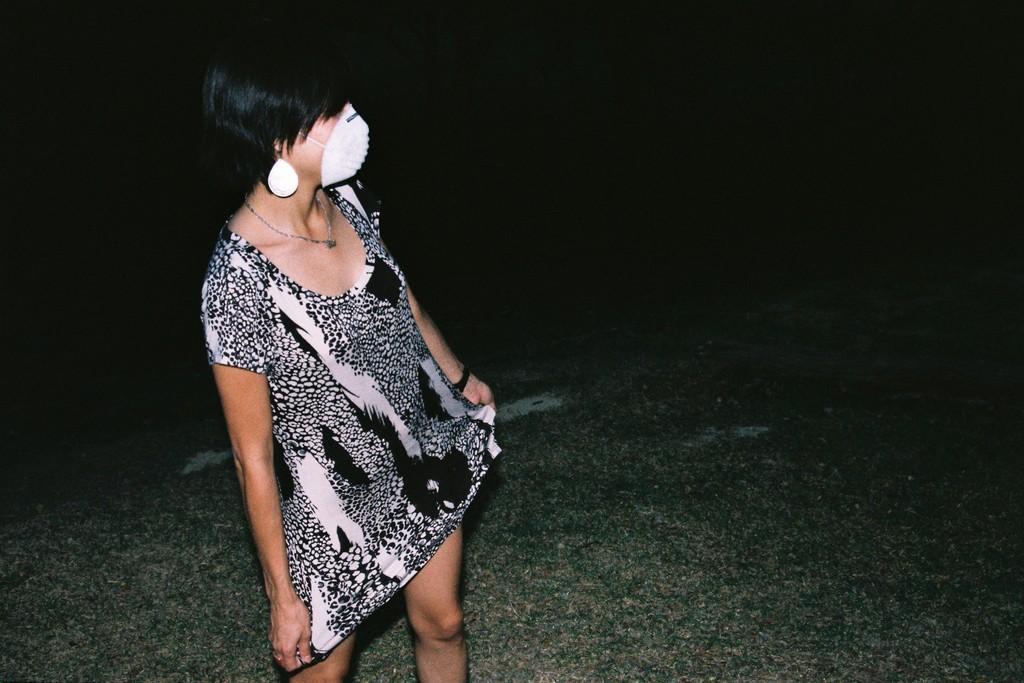Can you describe this image briefly? In this picture I can see a woman standing, she wore a mask on her face and I can see grass on the ground and I can see dark background. 